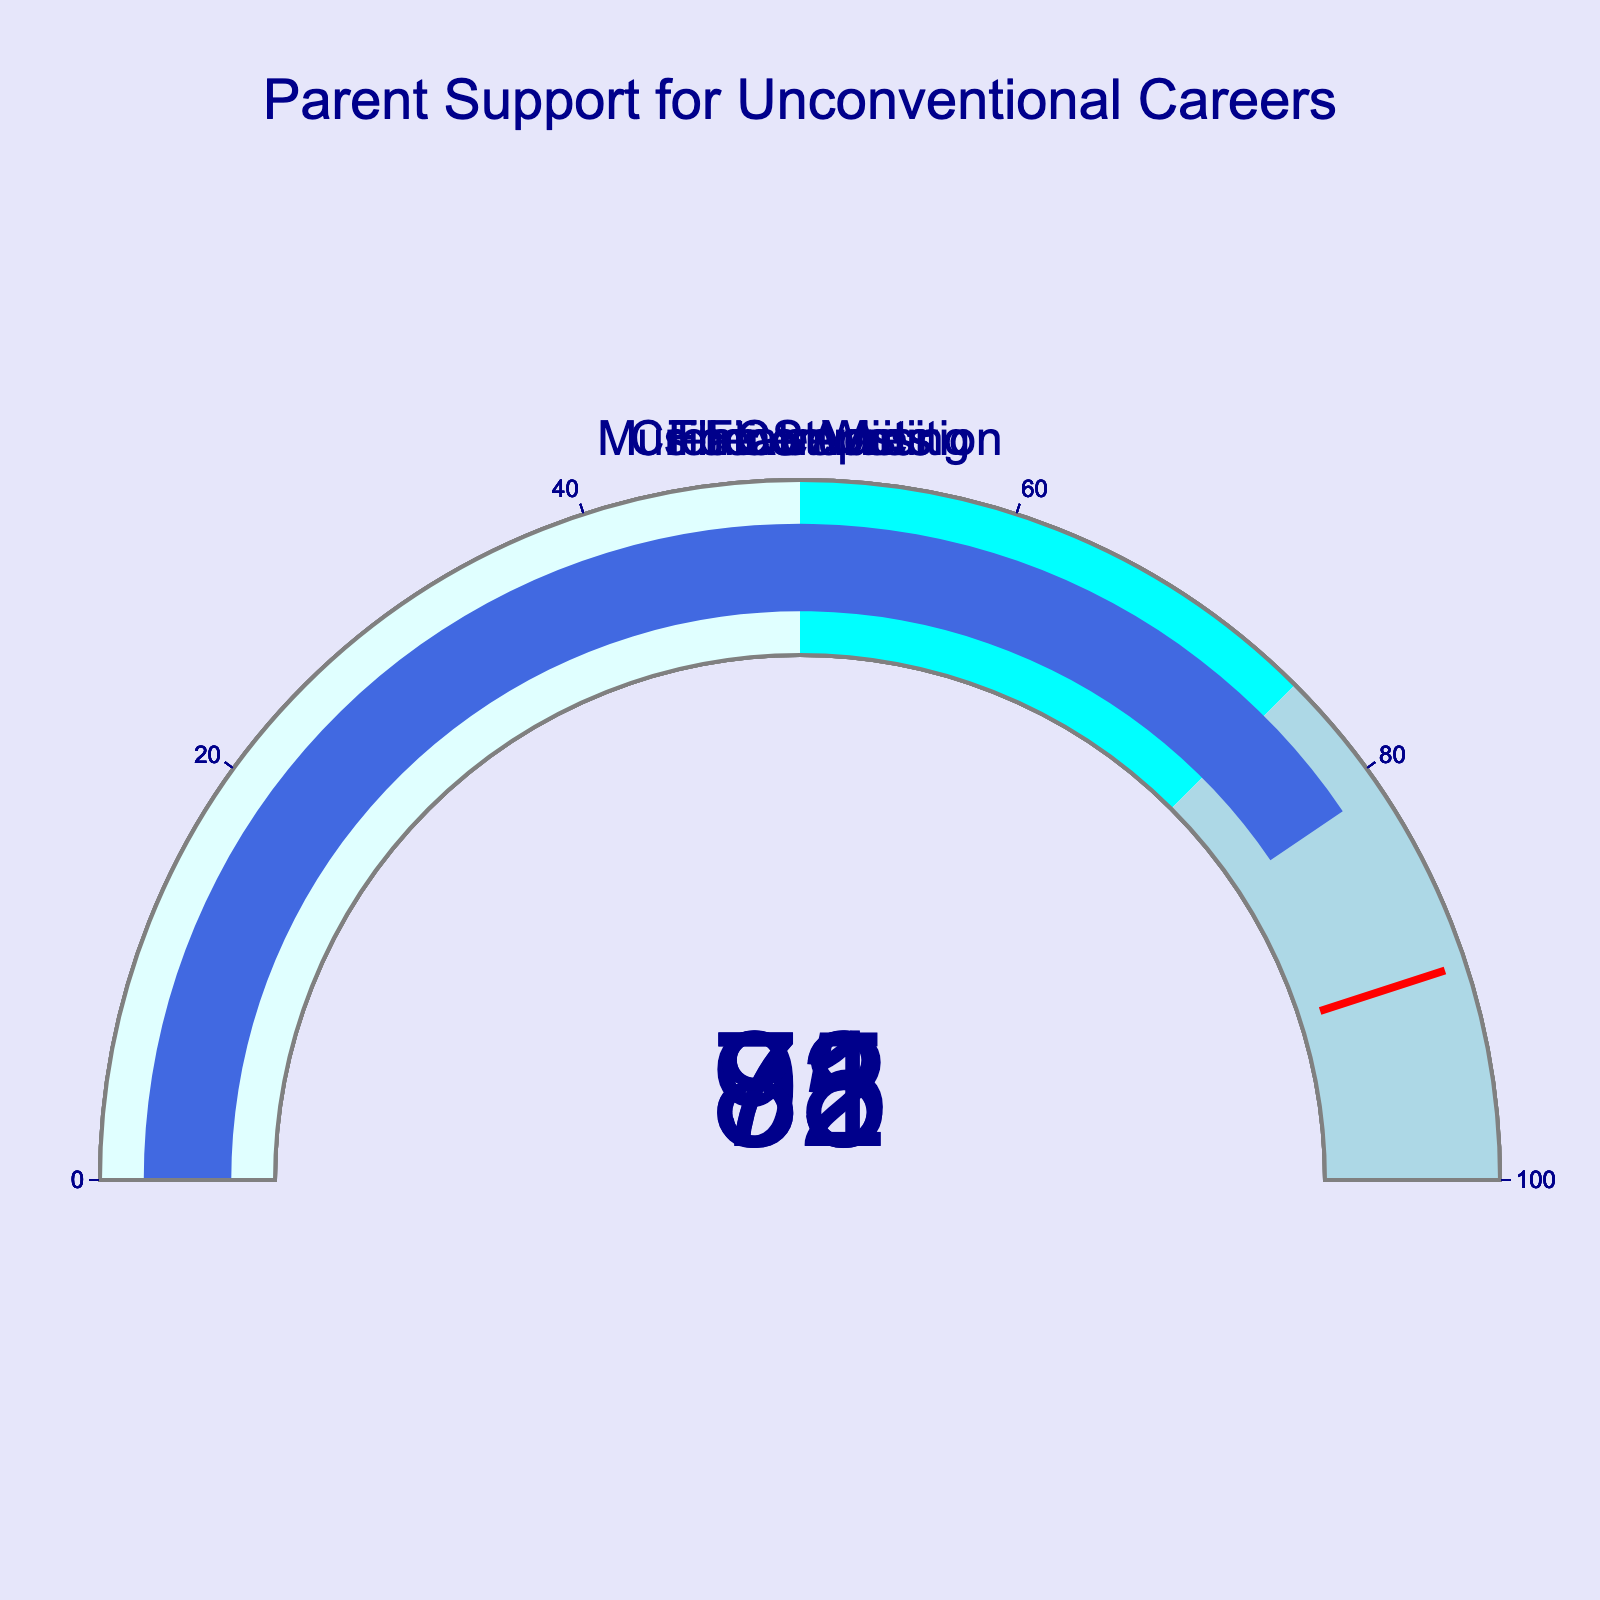What's the title of the figure? The title of the figure is typically displayed prominently, usually at the top.
Answer: Parent Support for Unconventional Careers How many career choices are shown in the figure? Count the number of unique gauge charts present in the figure.
Answer: 5 What is the highest support percentage shown, and which career does it correspond to? Look for the gauge chart with the highest value displayed, and note the career choice it represents.
Answer: 92, Film Studies Among all presented career options, which has the lowest support percentage? Identify the gauge chart with the smallest value displayed.
Answer: 73, Creative Writing What is the average support percentage across all career choices? Sum up all the percentages and divide by the number of career choices: (78+92+85+73+81)/5 = 409/5
Answer: 81.8 What color is used for the highest range in the gauges (75-100)? Examine the color-coded sections of the gauges to identify the color used for the highest range.
Answer: Light blue Which two career choices have the closest support percentages? Compare the percentages and find the two that are nearest to each other.
Answer: Music Composition (81) and Fine Arts (78) What is the sum of the support percentages for Theatre Arts and Music Composition? Add the support percentages for Theatre Arts and Music Composition: 85 + 81
Answer: 166 Are more than half of the displayed career choices supported by over 80% of parents? Count the number of career choices with support percentages above 80% and compare it to half the total number of career choices. 3 out of 5 is more than half.
Answer: Yes Of the career choices, which one surpasses the 90% support threshold? Look for the gauge chart that exceeds the 90% support mark.
Answer: Film Studies 